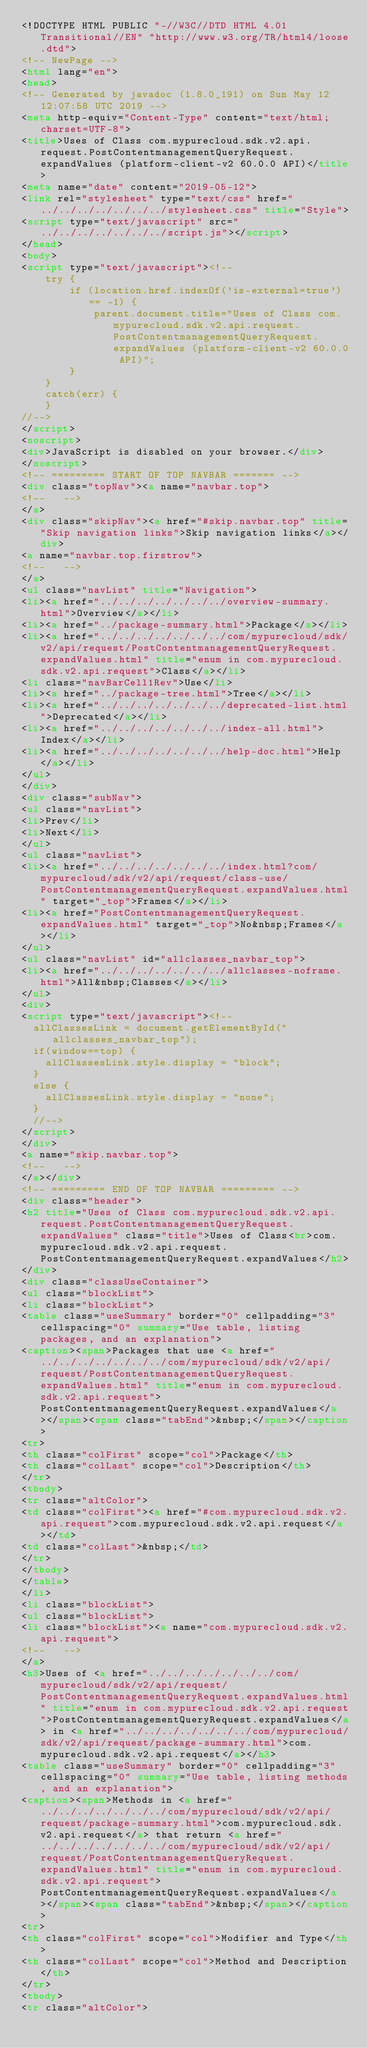<code> <loc_0><loc_0><loc_500><loc_500><_HTML_><!DOCTYPE HTML PUBLIC "-//W3C//DTD HTML 4.01 Transitional//EN" "http://www.w3.org/TR/html4/loose.dtd">
<!-- NewPage -->
<html lang="en">
<head>
<!-- Generated by javadoc (1.8.0_191) on Sun May 12 12:07:58 UTC 2019 -->
<meta http-equiv="Content-Type" content="text/html; charset=UTF-8">
<title>Uses of Class com.mypurecloud.sdk.v2.api.request.PostContentmanagementQueryRequest.expandValues (platform-client-v2 60.0.0 API)</title>
<meta name="date" content="2019-05-12">
<link rel="stylesheet" type="text/css" href="../../../../../../../stylesheet.css" title="Style">
<script type="text/javascript" src="../../../../../../../script.js"></script>
</head>
<body>
<script type="text/javascript"><!--
    try {
        if (location.href.indexOf('is-external=true') == -1) {
            parent.document.title="Uses of Class com.mypurecloud.sdk.v2.api.request.PostContentmanagementQueryRequest.expandValues (platform-client-v2 60.0.0 API)";
        }
    }
    catch(err) {
    }
//-->
</script>
<noscript>
<div>JavaScript is disabled on your browser.</div>
</noscript>
<!-- ========= START OF TOP NAVBAR ======= -->
<div class="topNav"><a name="navbar.top">
<!--   -->
</a>
<div class="skipNav"><a href="#skip.navbar.top" title="Skip navigation links">Skip navigation links</a></div>
<a name="navbar.top.firstrow">
<!--   -->
</a>
<ul class="navList" title="Navigation">
<li><a href="../../../../../../../overview-summary.html">Overview</a></li>
<li><a href="../package-summary.html">Package</a></li>
<li><a href="../../../../../../../com/mypurecloud/sdk/v2/api/request/PostContentmanagementQueryRequest.expandValues.html" title="enum in com.mypurecloud.sdk.v2.api.request">Class</a></li>
<li class="navBarCell1Rev">Use</li>
<li><a href="../package-tree.html">Tree</a></li>
<li><a href="../../../../../../../deprecated-list.html">Deprecated</a></li>
<li><a href="../../../../../../../index-all.html">Index</a></li>
<li><a href="../../../../../../../help-doc.html">Help</a></li>
</ul>
</div>
<div class="subNav">
<ul class="navList">
<li>Prev</li>
<li>Next</li>
</ul>
<ul class="navList">
<li><a href="../../../../../../../index.html?com/mypurecloud/sdk/v2/api/request/class-use/PostContentmanagementQueryRequest.expandValues.html" target="_top">Frames</a></li>
<li><a href="PostContentmanagementQueryRequest.expandValues.html" target="_top">No&nbsp;Frames</a></li>
</ul>
<ul class="navList" id="allclasses_navbar_top">
<li><a href="../../../../../../../allclasses-noframe.html">All&nbsp;Classes</a></li>
</ul>
<div>
<script type="text/javascript"><!--
  allClassesLink = document.getElementById("allclasses_navbar_top");
  if(window==top) {
    allClassesLink.style.display = "block";
  }
  else {
    allClassesLink.style.display = "none";
  }
  //-->
</script>
</div>
<a name="skip.navbar.top">
<!--   -->
</a></div>
<!-- ========= END OF TOP NAVBAR ========= -->
<div class="header">
<h2 title="Uses of Class com.mypurecloud.sdk.v2.api.request.PostContentmanagementQueryRequest.expandValues" class="title">Uses of Class<br>com.mypurecloud.sdk.v2.api.request.PostContentmanagementQueryRequest.expandValues</h2>
</div>
<div class="classUseContainer">
<ul class="blockList">
<li class="blockList">
<table class="useSummary" border="0" cellpadding="3" cellspacing="0" summary="Use table, listing packages, and an explanation">
<caption><span>Packages that use <a href="../../../../../../../com/mypurecloud/sdk/v2/api/request/PostContentmanagementQueryRequest.expandValues.html" title="enum in com.mypurecloud.sdk.v2.api.request">PostContentmanagementQueryRequest.expandValues</a></span><span class="tabEnd">&nbsp;</span></caption>
<tr>
<th class="colFirst" scope="col">Package</th>
<th class="colLast" scope="col">Description</th>
</tr>
<tbody>
<tr class="altColor">
<td class="colFirst"><a href="#com.mypurecloud.sdk.v2.api.request">com.mypurecloud.sdk.v2.api.request</a></td>
<td class="colLast">&nbsp;</td>
</tr>
</tbody>
</table>
</li>
<li class="blockList">
<ul class="blockList">
<li class="blockList"><a name="com.mypurecloud.sdk.v2.api.request">
<!--   -->
</a>
<h3>Uses of <a href="../../../../../../../com/mypurecloud/sdk/v2/api/request/PostContentmanagementQueryRequest.expandValues.html" title="enum in com.mypurecloud.sdk.v2.api.request">PostContentmanagementQueryRequest.expandValues</a> in <a href="../../../../../../../com/mypurecloud/sdk/v2/api/request/package-summary.html">com.mypurecloud.sdk.v2.api.request</a></h3>
<table class="useSummary" border="0" cellpadding="3" cellspacing="0" summary="Use table, listing methods, and an explanation">
<caption><span>Methods in <a href="../../../../../../../com/mypurecloud/sdk/v2/api/request/package-summary.html">com.mypurecloud.sdk.v2.api.request</a> that return <a href="../../../../../../../com/mypurecloud/sdk/v2/api/request/PostContentmanagementQueryRequest.expandValues.html" title="enum in com.mypurecloud.sdk.v2.api.request">PostContentmanagementQueryRequest.expandValues</a></span><span class="tabEnd">&nbsp;</span></caption>
<tr>
<th class="colFirst" scope="col">Modifier and Type</th>
<th class="colLast" scope="col">Method and Description</th>
</tr>
<tbody>
<tr class="altColor"></code> 